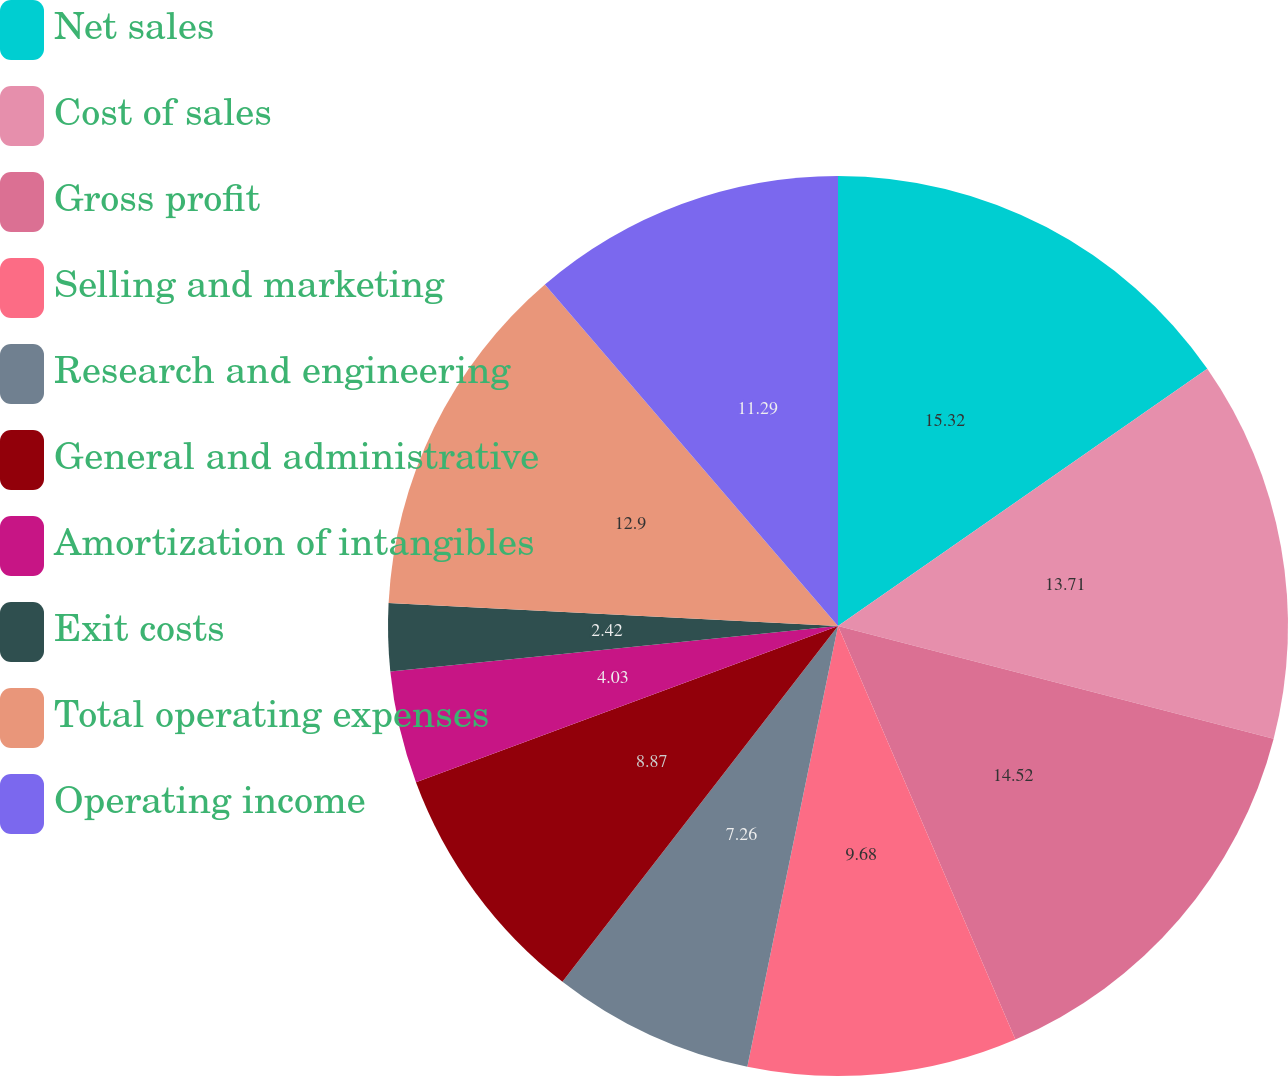<chart> <loc_0><loc_0><loc_500><loc_500><pie_chart><fcel>Net sales<fcel>Cost of sales<fcel>Gross profit<fcel>Selling and marketing<fcel>Research and engineering<fcel>General and administrative<fcel>Amortization of intangibles<fcel>Exit costs<fcel>Total operating expenses<fcel>Operating income<nl><fcel>15.32%<fcel>13.71%<fcel>14.52%<fcel>9.68%<fcel>7.26%<fcel>8.87%<fcel>4.03%<fcel>2.42%<fcel>12.9%<fcel>11.29%<nl></chart> 